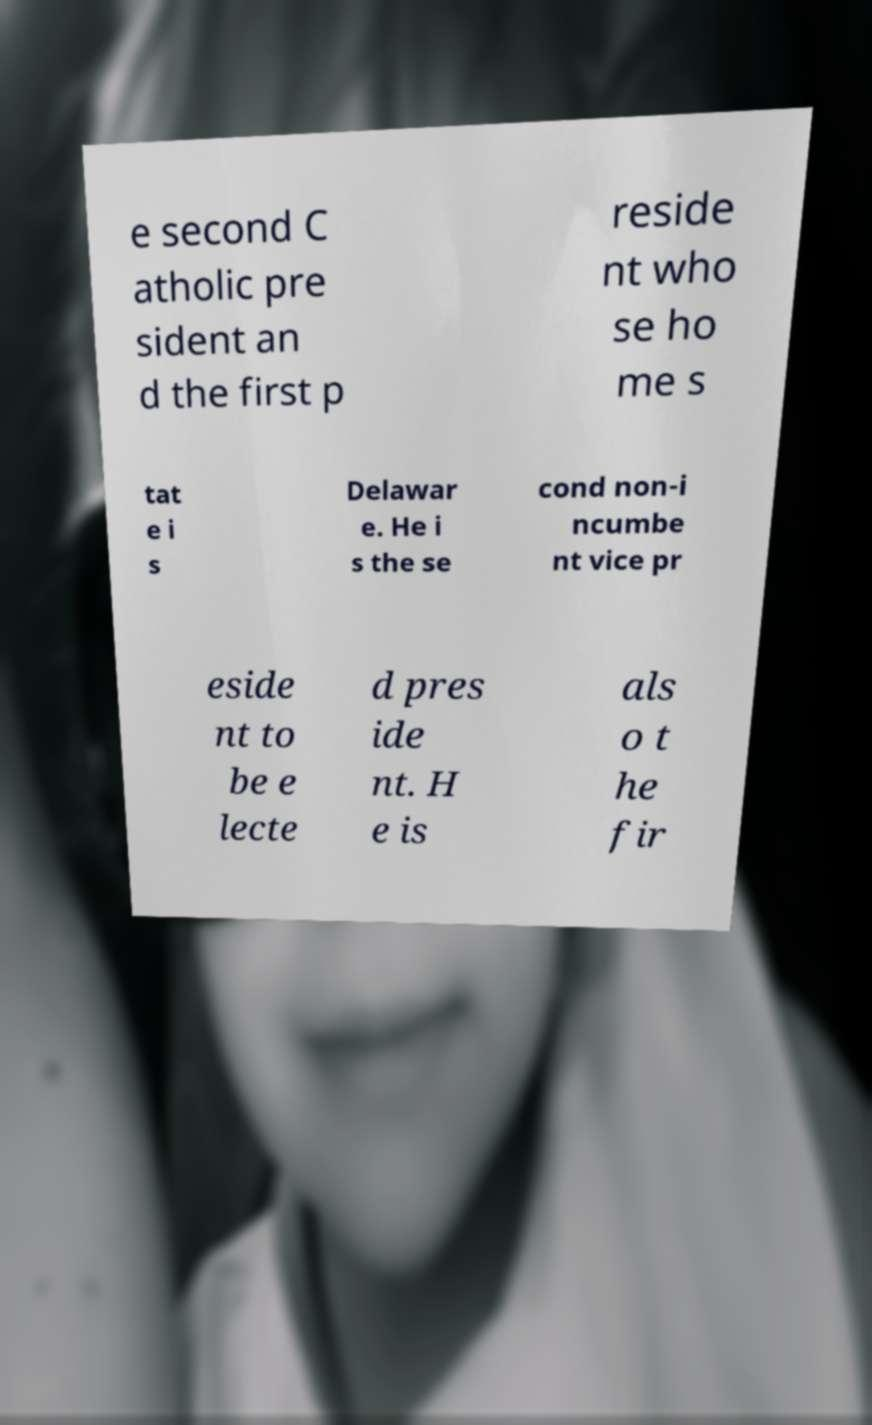For documentation purposes, I need the text within this image transcribed. Could you provide that? e second C atholic pre sident an d the first p reside nt who se ho me s tat e i s Delawar e. He i s the se cond non-i ncumbe nt vice pr eside nt to be e lecte d pres ide nt. H e is als o t he fir 